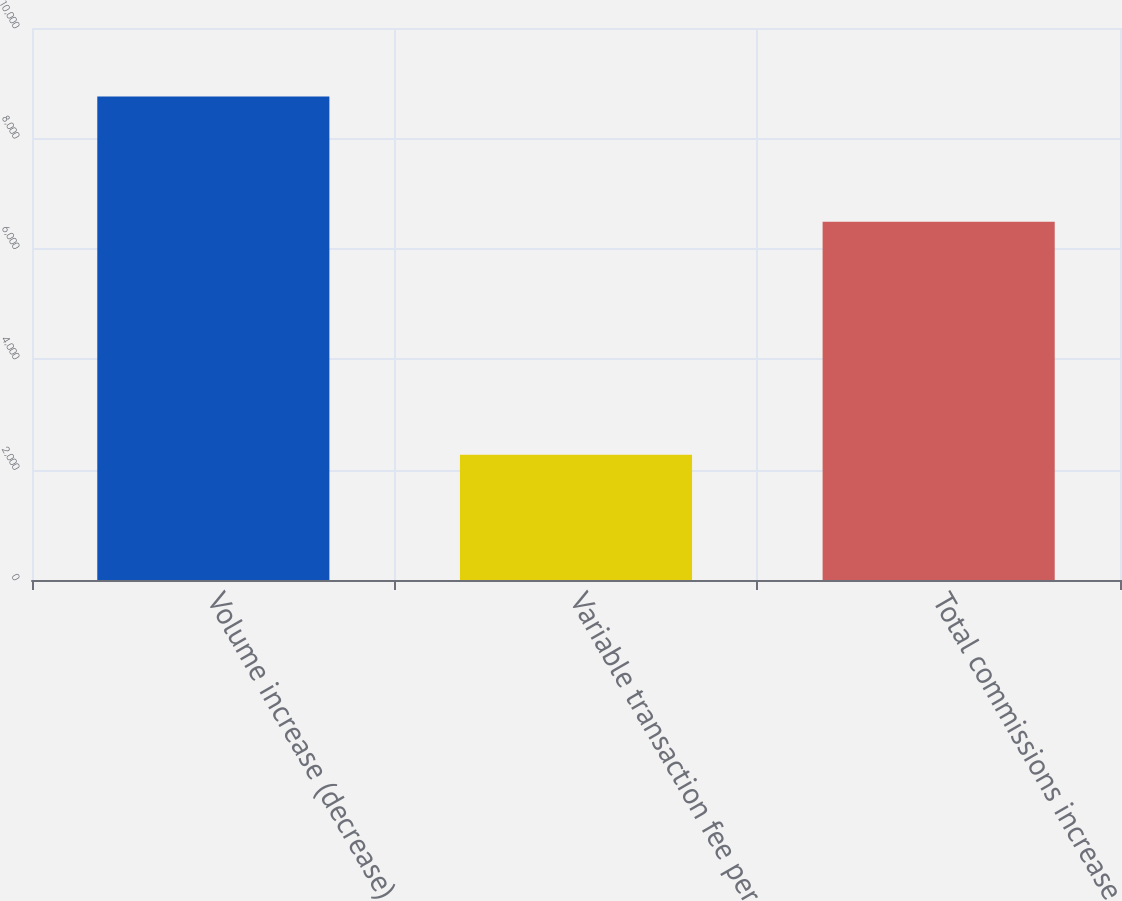Convert chart. <chart><loc_0><loc_0><loc_500><loc_500><bar_chart><fcel>Volume increase (decrease)<fcel>Variable transaction fee per<fcel>Total commissions increase<nl><fcel>8759<fcel>2267<fcel>6492<nl></chart> 